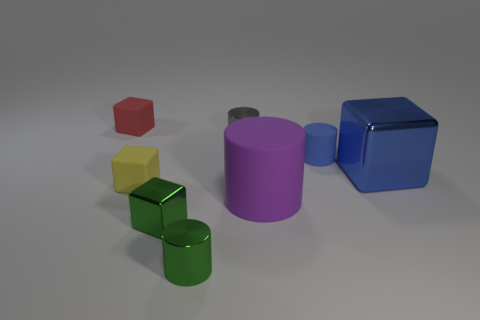Add 1 tiny cubes. How many objects exist? 9 Subtract 0 green spheres. How many objects are left? 8 Subtract all small green shiny cylinders. Subtract all big objects. How many objects are left? 5 Add 4 green cylinders. How many green cylinders are left? 5 Add 7 large gray blocks. How many large gray blocks exist? 7 